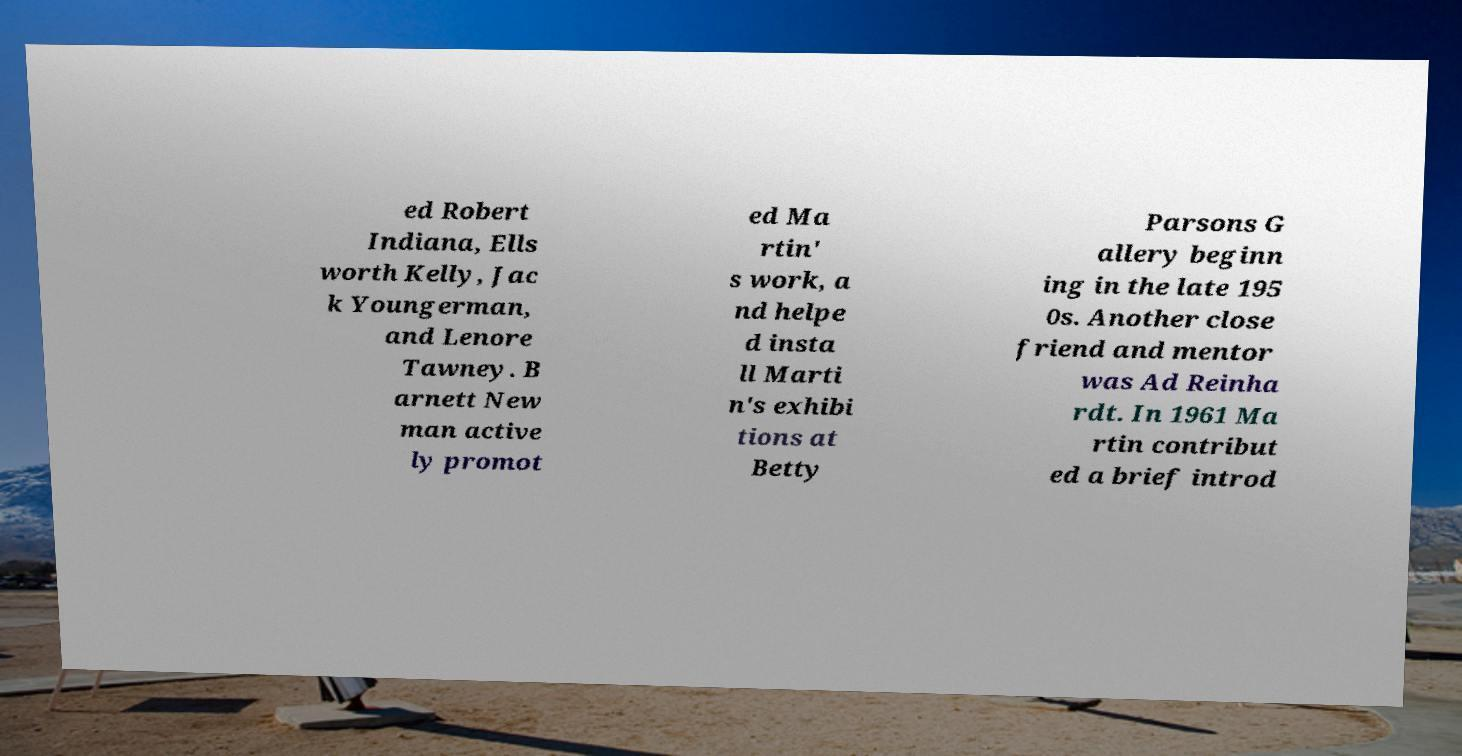I need the written content from this picture converted into text. Can you do that? ed Robert Indiana, Ells worth Kelly, Jac k Youngerman, and Lenore Tawney. B arnett New man active ly promot ed Ma rtin' s work, a nd helpe d insta ll Marti n's exhibi tions at Betty Parsons G allery beginn ing in the late 195 0s. Another close friend and mentor was Ad Reinha rdt. In 1961 Ma rtin contribut ed a brief introd 